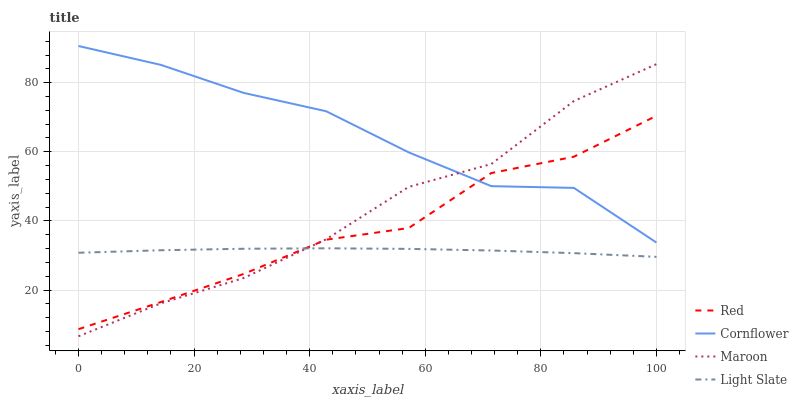Does Light Slate have the minimum area under the curve?
Answer yes or no. Yes. Does Cornflower have the maximum area under the curve?
Answer yes or no. Yes. Does Maroon have the minimum area under the curve?
Answer yes or no. No. Does Maroon have the maximum area under the curve?
Answer yes or no. No. Is Light Slate the smoothest?
Answer yes or no. Yes. Is Red the roughest?
Answer yes or no. Yes. Is Cornflower the smoothest?
Answer yes or no. No. Is Cornflower the roughest?
Answer yes or no. No. Does Maroon have the lowest value?
Answer yes or no. Yes. Does Cornflower have the lowest value?
Answer yes or no. No. Does Cornflower have the highest value?
Answer yes or no. Yes. Does Maroon have the highest value?
Answer yes or no. No. Is Light Slate less than Cornflower?
Answer yes or no. Yes. Is Cornflower greater than Light Slate?
Answer yes or no. Yes. Does Maroon intersect Light Slate?
Answer yes or no. Yes. Is Maroon less than Light Slate?
Answer yes or no. No. Is Maroon greater than Light Slate?
Answer yes or no. No. Does Light Slate intersect Cornflower?
Answer yes or no. No. 